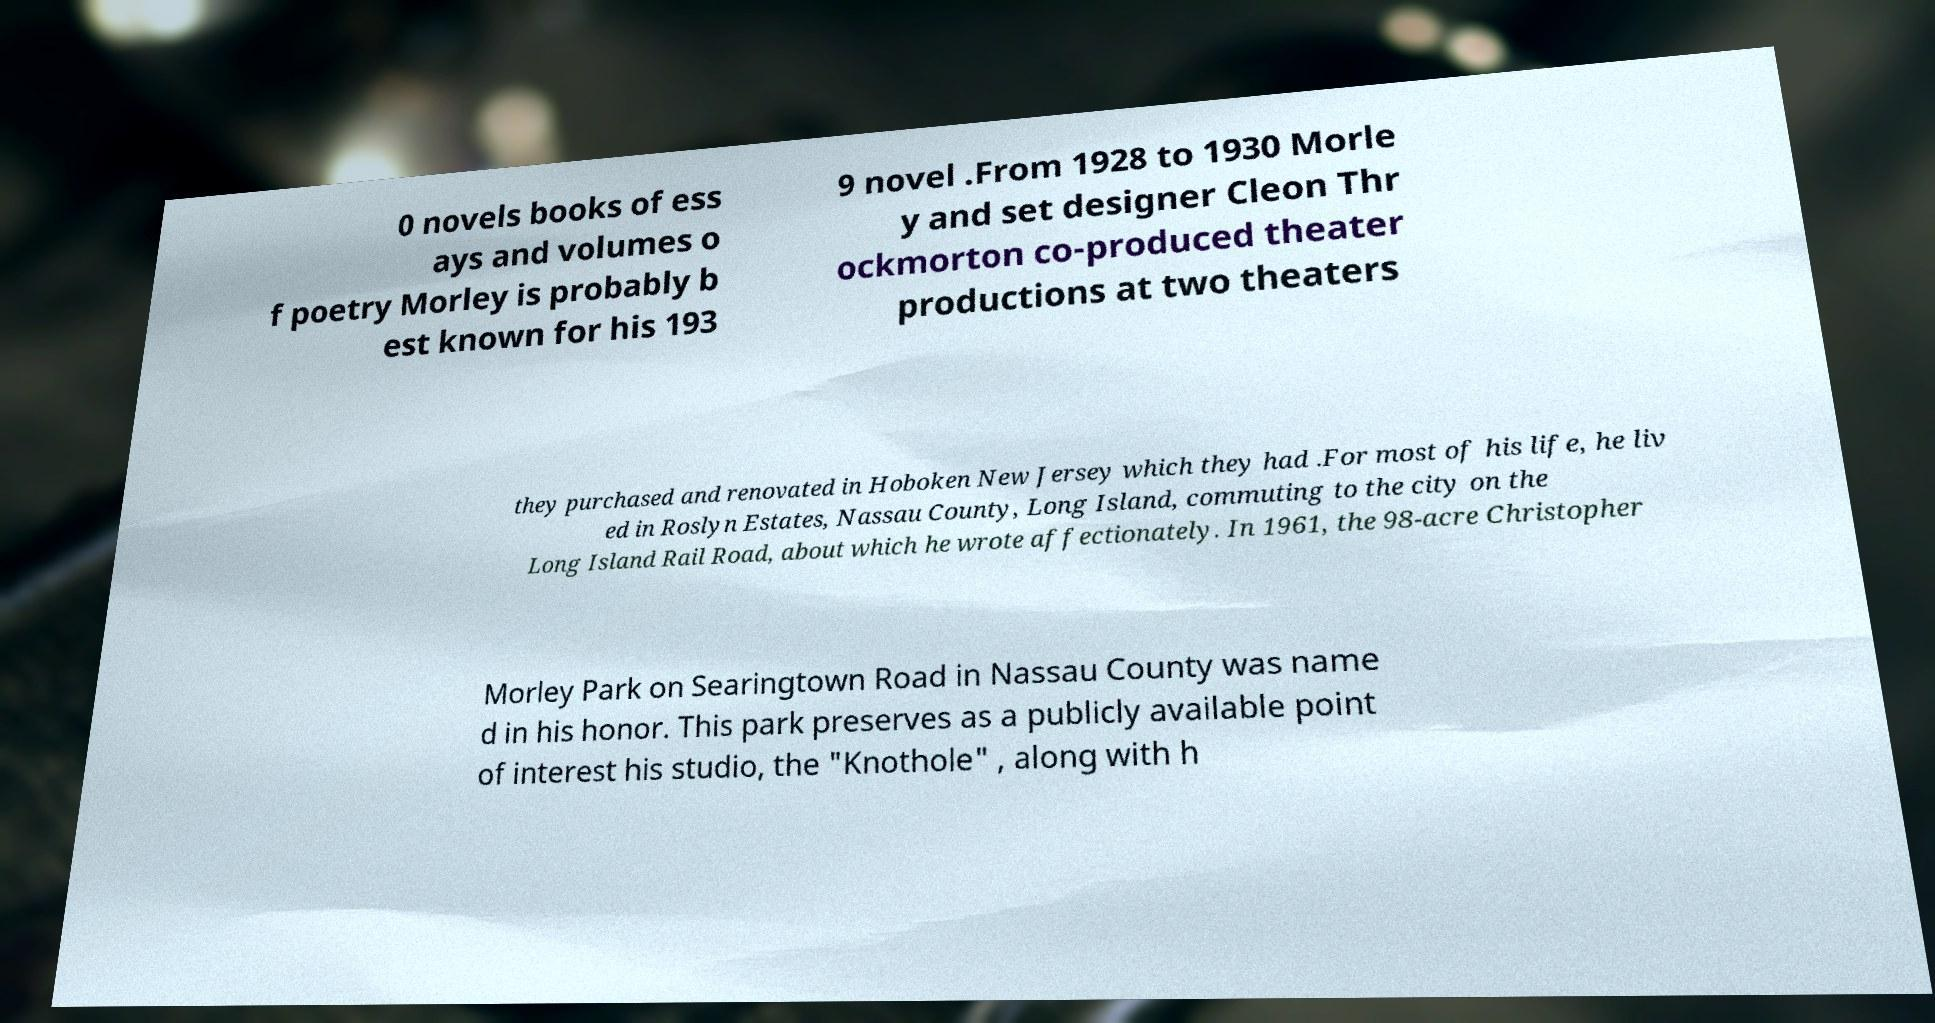Please read and relay the text visible in this image. What does it say? 0 novels books of ess ays and volumes o f poetry Morley is probably b est known for his 193 9 novel .From 1928 to 1930 Morle y and set designer Cleon Thr ockmorton co-produced theater productions at two theaters they purchased and renovated in Hoboken New Jersey which they had .For most of his life, he liv ed in Roslyn Estates, Nassau County, Long Island, commuting to the city on the Long Island Rail Road, about which he wrote affectionately. In 1961, the 98-acre Christopher Morley Park on Searingtown Road in Nassau County was name d in his honor. This park preserves as a publicly available point of interest his studio, the "Knothole" , along with h 